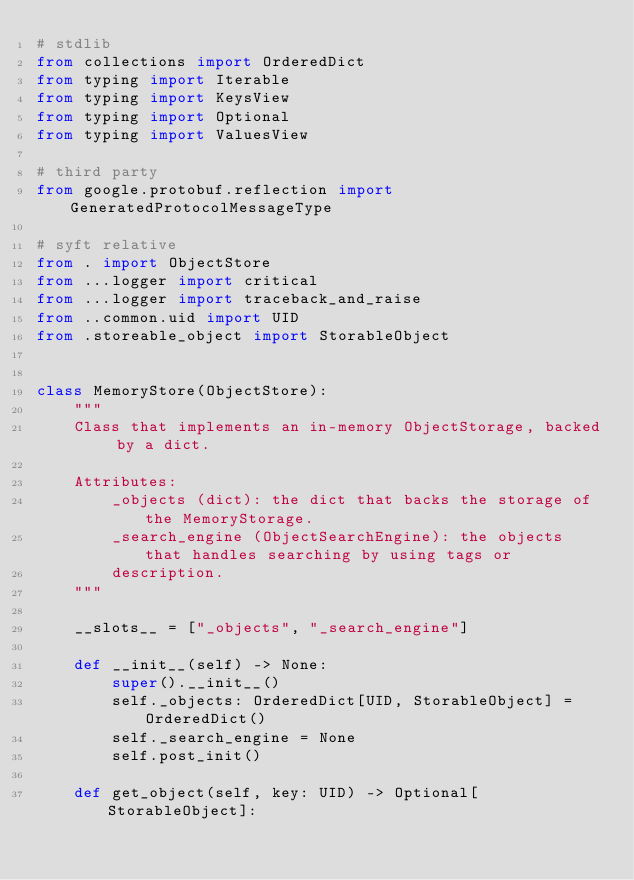<code> <loc_0><loc_0><loc_500><loc_500><_Python_># stdlib
from collections import OrderedDict
from typing import Iterable
from typing import KeysView
from typing import Optional
from typing import ValuesView

# third party
from google.protobuf.reflection import GeneratedProtocolMessageType

# syft relative
from . import ObjectStore
from ...logger import critical
from ...logger import traceback_and_raise
from ..common.uid import UID
from .storeable_object import StorableObject


class MemoryStore(ObjectStore):
    """
    Class that implements an in-memory ObjectStorage, backed by a dict.

    Attributes:
        _objects (dict): the dict that backs the storage of the MemoryStorage.
        _search_engine (ObjectSearchEngine): the objects that handles searching by using tags or
        description.
    """

    __slots__ = ["_objects", "_search_engine"]

    def __init__(self) -> None:
        super().__init__()
        self._objects: OrderedDict[UID, StorableObject] = OrderedDict()
        self._search_engine = None
        self.post_init()

    def get_object(self, key: UID) -> Optional[StorableObject]:</code> 